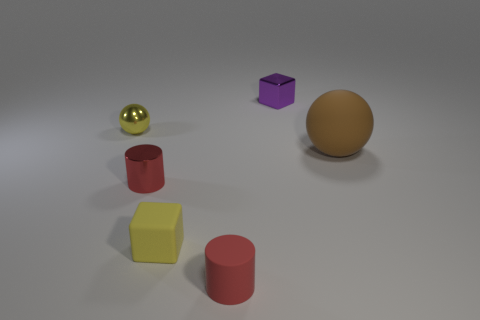Is the color of the metal sphere the same as the rubber block?
Provide a short and direct response. Yes. There is a metallic ball that is the same color as the rubber block; what size is it?
Your response must be concise. Small. There is a tiny rubber thing that is the same color as the metal ball; what shape is it?
Ensure brevity in your answer.  Cube. The small object that is behind the small yellow object on the left side of the tiny cube in front of the metal block is what color?
Your answer should be compact. Purple. How many tiny shiny objects have the same shape as the red rubber object?
Your answer should be compact. 1. There is a sphere that is left of the shiny thing behind the tiny sphere; what size is it?
Offer a terse response. Small. Do the matte ball and the red metal cylinder have the same size?
Ensure brevity in your answer.  No. Are there any red cylinders in front of the block that is to the left of the cube behind the large matte thing?
Offer a terse response. Yes. The purple cube has what size?
Offer a terse response. Small. What number of rubber blocks have the same size as the red metallic cylinder?
Provide a short and direct response. 1. 